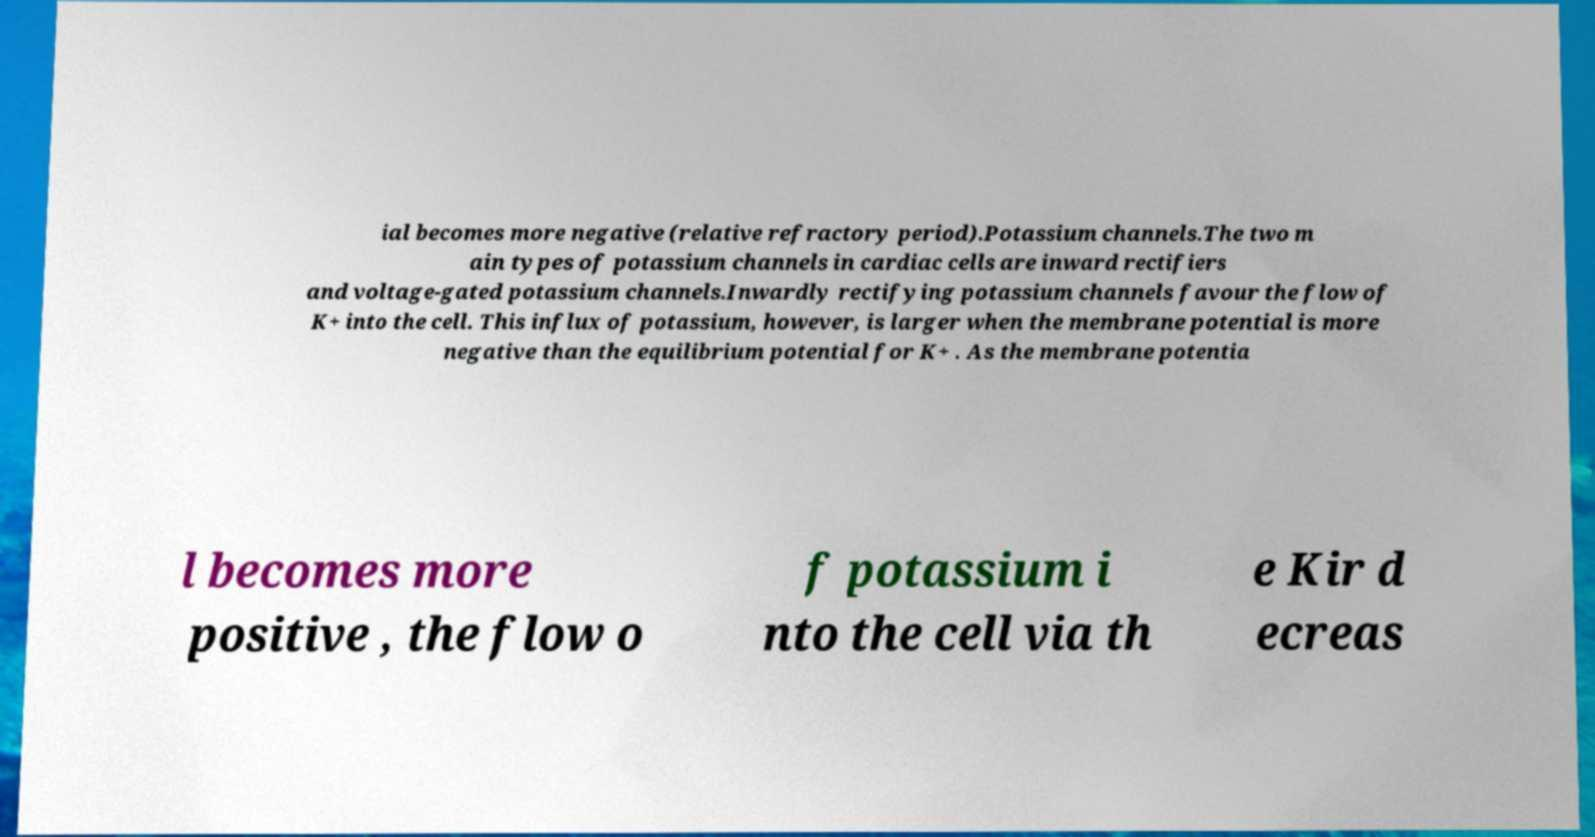Please identify and transcribe the text found in this image. ial becomes more negative (relative refractory period).Potassium channels.The two m ain types of potassium channels in cardiac cells are inward rectifiers and voltage-gated potassium channels.Inwardly rectifying potassium channels favour the flow of K+ into the cell. This influx of potassium, however, is larger when the membrane potential is more negative than the equilibrium potential for K+ . As the membrane potentia l becomes more positive , the flow o f potassium i nto the cell via th e Kir d ecreas 